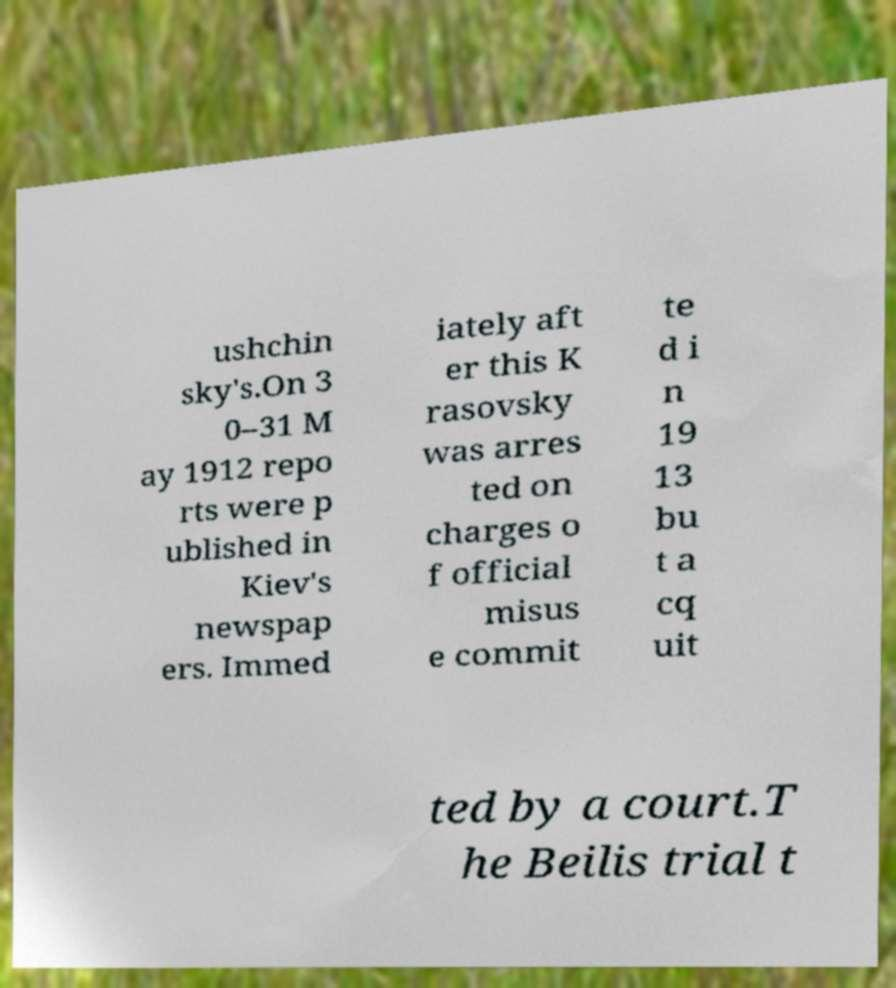Can you read and provide the text displayed in the image?This photo seems to have some interesting text. Can you extract and type it out for me? ushchin sky's.On 3 0–31 M ay 1912 repo rts were p ublished in Kiev's newspap ers. Immed iately aft er this K rasovsky was arres ted on charges o f official misus e commit te d i n 19 13 bu t a cq uit ted by a court.T he Beilis trial t 